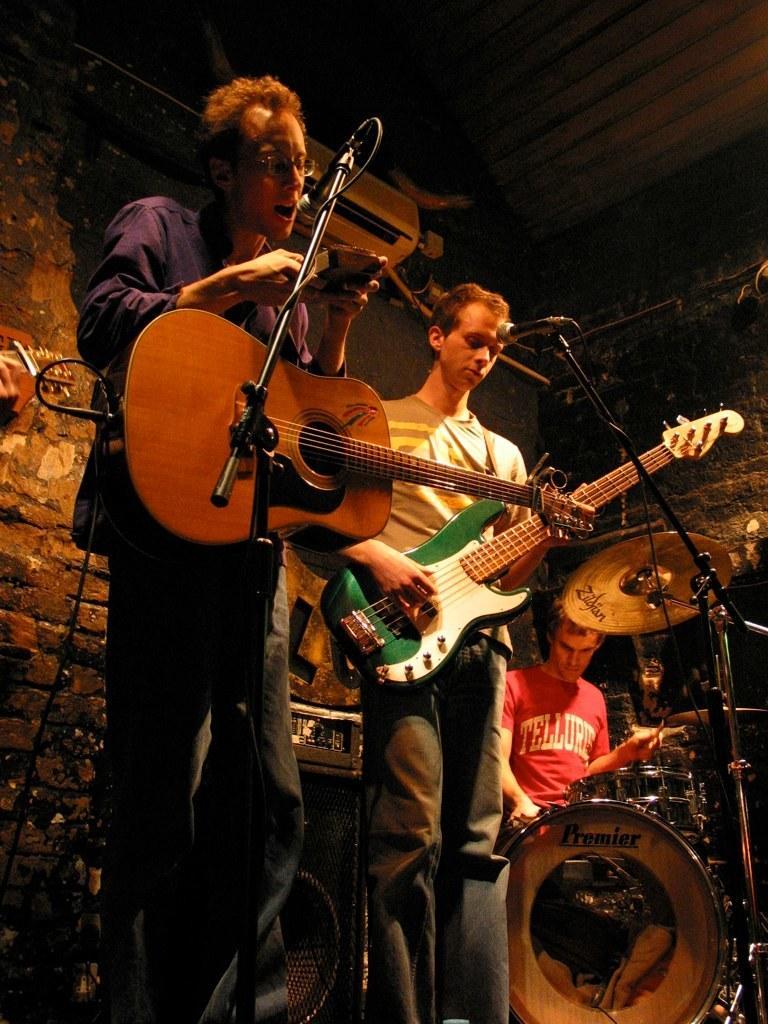Could you give a brief overview of what you see in this image? In this image there are people who are playing musical instruments. There are guitars, drums and mike's. There is a wall in the background. There is an AC on the top. 